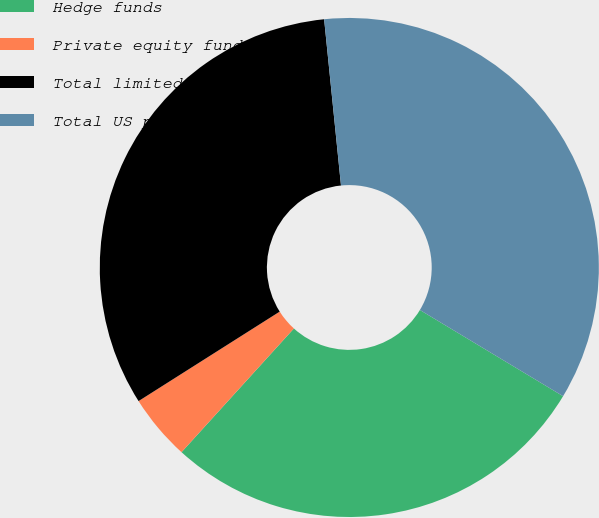Convert chart to OTSL. <chart><loc_0><loc_0><loc_500><loc_500><pie_chart><fcel>Hedge funds<fcel>Private equity funds<fcel>Total limited partnerships<fcel>Total US plans<nl><fcel>28.11%<fcel>4.27%<fcel>32.38%<fcel>35.23%<nl></chart> 